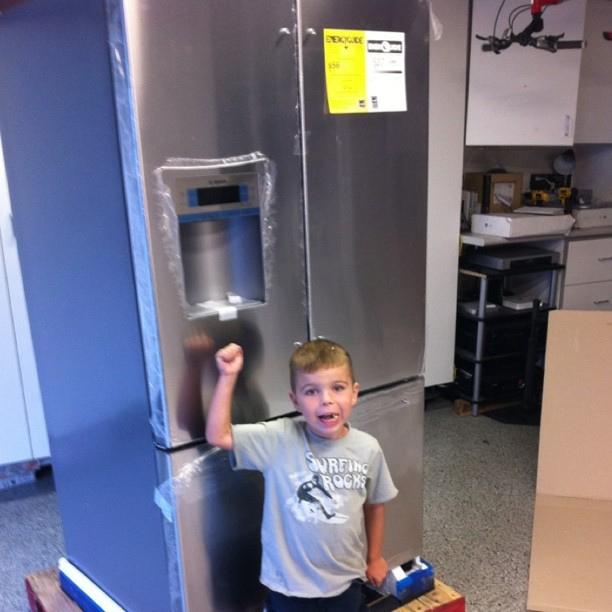Is the fridge new?
Quick response, please. Yes. What material is the refrigerator made of?
Answer briefly. Stainless steel. What is the kid looking at?
Short answer required. Camera. 